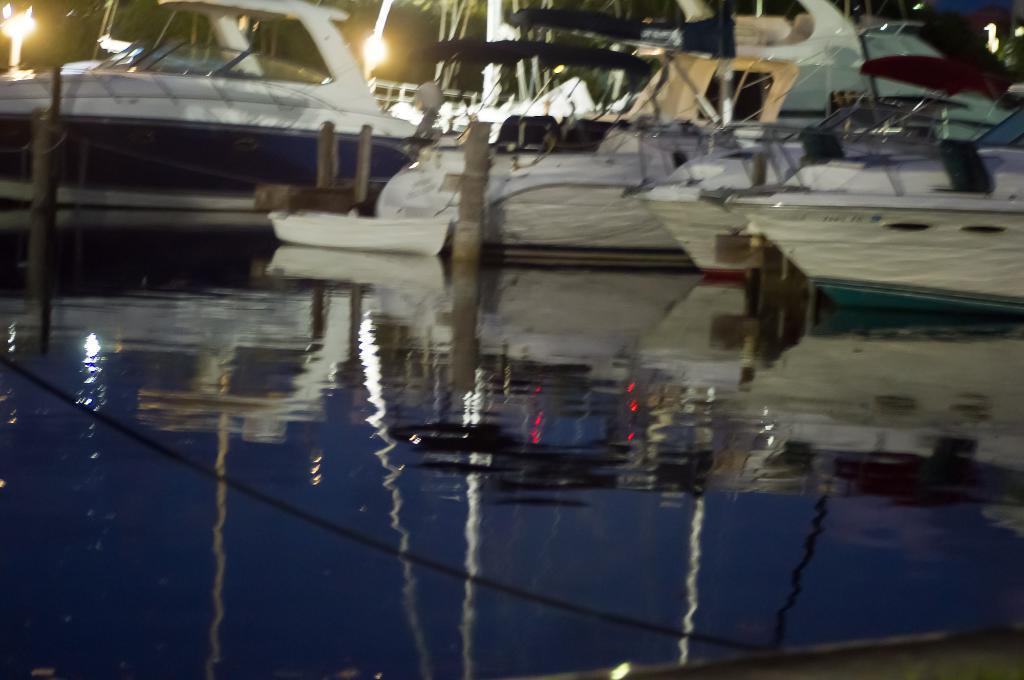How would you summarize this image in a sentence or two? In this image there is water at the bottom and we can see the reflection of ships in the water. And we can see ships with poles. 